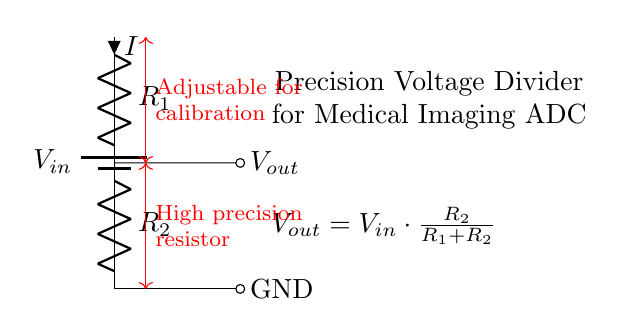What is the input voltage in this circuit? The circuit shows a battery labeled \(V_{in}\), which indicates that it is the input voltage. Since no specific value is given in the visual representation, we can only refer to it as \(V_{in}\).
Answer: \(V_{in}\) What are the resistor values? The diagram labels resistors as \(R_1\) and \(R_2\), but no specific numerical values are provided. The configuration shows them in a voltage divider setup, indicating they are of certain values relevant for precise voltage division.
Answer: \(R_1, R_2\) What is the purpose of the voltage divider in this setup? The voltage divider is used to scale down the input voltage \(V_{in}\) to produce a lower output voltage \(V_{out}\) suitable for analog-to-digital conversion in medical imaging equipment.
Answer: Voltage scaling How is the output voltage calculated? The output voltage \(V_{out}\) is calculated using the formula \(V_{out} = V_{in} \cdot \frac{R_2}{R_1 + R_2}\). This formula shows the relationship between the input voltage, the resistors \(R_1\) and \(R_2\), and the output voltage.
Answer: \(V_{in} \cdot \frac{R_2}{R_1 + R_2}\) What do the adjustable and high precision resistor labels signify? The labels indicate that \(R_1\) is adjustable for calibration purposes, and that the voltage divider includes high precision resistors, which are important for ensuring accurate voltage division crucial for medical applications.
Answer: Calibration and precision What is the output reference point in this circuit? The output reference point is indicated by the GND label, which represents the ground or zero voltage level in the circuit, alongside the output voltage \(V_{out}\).
Answer: GND 